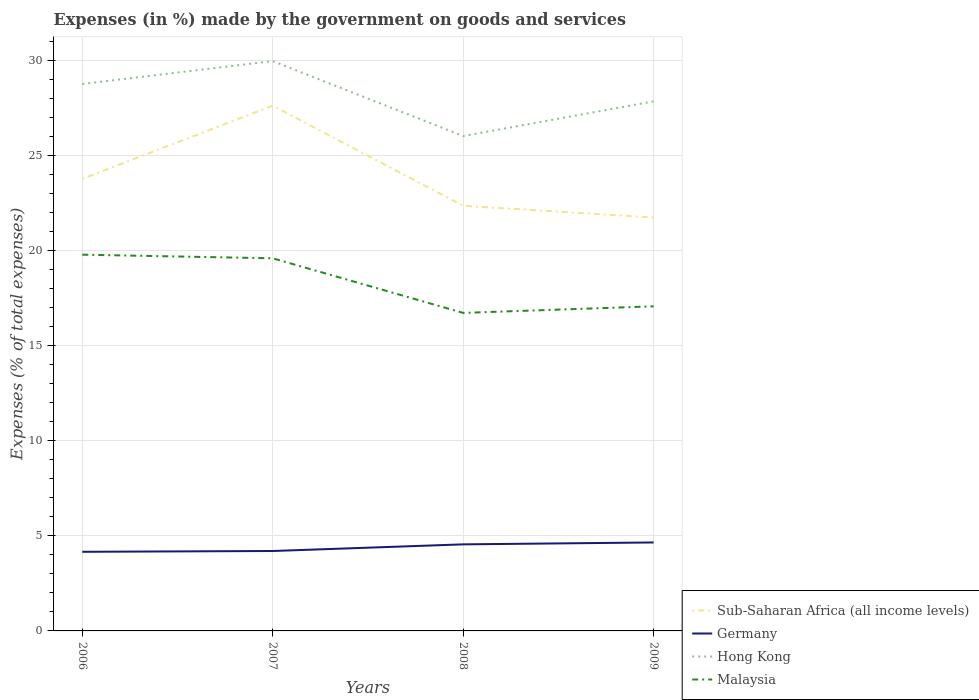Does the line corresponding to Malaysia intersect with the line corresponding to Hong Kong?
Keep it short and to the point. No. Across all years, what is the maximum percentage of expenses made by the government on goods and services in Malaysia?
Keep it short and to the point. 16.72. What is the total percentage of expenses made by the government on goods and services in Germany in the graph?
Offer a very short reply. -0.35. What is the difference between the highest and the second highest percentage of expenses made by the government on goods and services in Sub-Saharan Africa (all income levels)?
Offer a terse response. 5.88. What is the difference between the highest and the lowest percentage of expenses made by the government on goods and services in Malaysia?
Provide a short and direct response. 2. Is the percentage of expenses made by the government on goods and services in Germany strictly greater than the percentage of expenses made by the government on goods and services in Malaysia over the years?
Provide a short and direct response. Yes. How many lines are there?
Offer a very short reply. 4. What is the difference between two consecutive major ticks on the Y-axis?
Ensure brevity in your answer.  5. How are the legend labels stacked?
Offer a very short reply. Vertical. What is the title of the graph?
Provide a succinct answer. Expenses (in %) made by the government on goods and services. What is the label or title of the Y-axis?
Ensure brevity in your answer.  Expenses (% of total expenses). What is the Expenses (% of total expenses) in Sub-Saharan Africa (all income levels) in 2006?
Provide a succinct answer. 23.77. What is the Expenses (% of total expenses) of Germany in 2006?
Your answer should be compact. 4.16. What is the Expenses (% of total expenses) of Hong Kong in 2006?
Offer a terse response. 28.76. What is the Expenses (% of total expenses) in Malaysia in 2006?
Make the answer very short. 19.79. What is the Expenses (% of total expenses) in Sub-Saharan Africa (all income levels) in 2007?
Your response must be concise. 27.62. What is the Expenses (% of total expenses) of Germany in 2007?
Keep it short and to the point. 4.2. What is the Expenses (% of total expenses) of Hong Kong in 2007?
Provide a short and direct response. 29.97. What is the Expenses (% of total expenses) in Malaysia in 2007?
Offer a very short reply. 19.6. What is the Expenses (% of total expenses) in Sub-Saharan Africa (all income levels) in 2008?
Give a very brief answer. 22.36. What is the Expenses (% of total expenses) in Germany in 2008?
Offer a very short reply. 4.55. What is the Expenses (% of total expenses) in Hong Kong in 2008?
Give a very brief answer. 26.02. What is the Expenses (% of total expenses) of Malaysia in 2008?
Give a very brief answer. 16.72. What is the Expenses (% of total expenses) in Sub-Saharan Africa (all income levels) in 2009?
Your answer should be compact. 21.74. What is the Expenses (% of total expenses) in Germany in 2009?
Your response must be concise. 4.65. What is the Expenses (% of total expenses) in Hong Kong in 2009?
Offer a very short reply. 27.85. What is the Expenses (% of total expenses) of Malaysia in 2009?
Keep it short and to the point. 17.07. Across all years, what is the maximum Expenses (% of total expenses) of Sub-Saharan Africa (all income levels)?
Keep it short and to the point. 27.62. Across all years, what is the maximum Expenses (% of total expenses) in Germany?
Your answer should be compact. 4.65. Across all years, what is the maximum Expenses (% of total expenses) in Hong Kong?
Ensure brevity in your answer.  29.97. Across all years, what is the maximum Expenses (% of total expenses) in Malaysia?
Offer a terse response. 19.79. Across all years, what is the minimum Expenses (% of total expenses) in Sub-Saharan Africa (all income levels)?
Provide a succinct answer. 21.74. Across all years, what is the minimum Expenses (% of total expenses) in Germany?
Give a very brief answer. 4.16. Across all years, what is the minimum Expenses (% of total expenses) in Hong Kong?
Your response must be concise. 26.02. Across all years, what is the minimum Expenses (% of total expenses) of Malaysia?
Give a very brief answer. 16.72. What is the total Expenses (% of total expenses) in Sub-Saharan Africa (all income levels) in the graph?
Ensure brevity in your answer.  95.49. What is the total Expenses (% of total expenses) of Germany in the graph?
Your answer should be compact. 17.57. What is the total Expenses (% of total expenses) in Hong Kong in the graph?
Ensure brevity in your answer.  112.6. What is the total Expenses (% of total expenses) of Malaysia in the graph?
Your response must be concise. 73.18. What is the difference between the Expenses (% of total expenses) in Sub-Saharan Africa (all income levels) in 2006 and that in 2007?
Ensure brevity in your answer.  -3.85. What is the difference between the Expenses (% of total expenses) in Germany in 2006 and that in 2007?
Offer a terse response. -0.04. What is the difference between the Expenses (% of total expenses) of Hong Kong in 2006 and that in 2007?
Make the answer very short. -1.2. What is the difference between the Expenses (% of total expenses) of Malaysia in 2006 and that in 2007?
Offer a very short reply. 0.19. What is the difference between the Expenses (% of total expenses) in Sub-Saharan Africa (all income levels) in 2006 and that in 2008?
Offer a very short reply. 1.42. What is the difference between the Expenses (% of total expenses) of Germany in 2006 and that in 2008?
Offer a terse response. -0.39. What is the difference between the Expenses (% of total expenses) in Hong Kong in 2006 and that in 2008?
Give a very brief answer. 2.74. What is the difference between the Expenses (% of total expenses) in Malaysia in 2006 and that in 2008?
Make the answer very short. 3.06. What is the difference between the Expenses (% of total expenses) of Sub-Saharan Africa (all income levels) in 2006 and that in 2009?
Keep it short and to the point. 2.03. What is the difference between the Expenses (% of total expenses) in Germany in 2006 and that in 2009?
Ensure brevity in your answer.  -0.49. What is the difference between the Expenses (% of total expenses) in Hong Kong in 2006 and that in 2009?
Offer a very short reply. 0.91. What is the difference between the Expenses (% of total expenses) in Malaysia in 2006 and that in 2009?
Ensure brevity in your answer.  2.72. What is the difference between the Expenses (% of total expenses) of Sub-Saharan Africa (all income levels) in 2007 and that in 2008?
Ensure brevity in your answer.  5.26. What is the difference between the Expenses (% of total expenses) in Germany in 2007 and that in 2008?
Your answer should be very brief. -0.35. What is the difference between the Expenses (% of total expenses) of Hong Kong in 2007 and that in 2008?
Keep it short and to the point. 3.94. What is the difference between the Expenses (% of total expenses) of Malaysia in 2007 and that in 2008?
Your answer should be very brief. 2.87. What is the difference between the Expenses (% of total expenses) of Sub-Saharan Africa (all income levels) in 2007 and that in 2009?
Offer a terse response. 5.88. What is the difference between the Expenses (% of total expenses) in Germany in 2007 and that in 2009?
Your answer should be compact. -0.45. What is the difference between the Expenses (% of total expenses) of Hong Kong in 2007 and that in 2009?
Keep it short and to the point. 2.12. What is the difference between the Expenses (% of total expenses) in Malaysia in 2007 and that in 2009?
Make the answer very short. 2.52. What is the difference between the Expenses (% of total expenses) in Sub-Saharan Africa (all income levels) in 2008 and that in 2009?
Offer a very short reply. 0.62. What is the difference between the Expenses (% of total expenses) of Germany in 2008 and that in 2009?
Your answer should be very brief. -0.1. What is the difference between the Expenses (% of total expenses) in Hong Kong in 2008 and that in 2009?
Give a very brief answer. -1.82. What is the difference between the Expenses (% of total expenses) of Malaysia in 2008 and that in 2009?
Offer a terse response. -0.35. What is the difference between the Expenses (% of total expenses) in Sub-Saharan Africa (all income levels) in 2006 and the Expenses (% of total expenses) in Germany in 2007?
Offer a terse response. 19.57. What is the difference between the Expenses (% of total expenses) of Sub-Saharan Africa (all income levels) in 2006 and the Expenses (% of total expenses) of Hong Kong in 2007?
Make the answer very short. -6.19. What is the difference between the Expenses (% of total expenses) in Sub-Saharan Africa (all income levels) in 2006 and the Expenses (% of total expenses) in Malaysia in 2007?
Your response must be concise. 4.18. What is the difference between the Expenses (% of total expenses) in Germany in 2006 and the Expenses (% of total expenses) in Hong Kong in 2007?
Ensure brevity in your answer.  -25.8. What is the difference between the Expenses (% of total expenses) in Germany in 2006 and the Expenses (% of total expenses) in Malaysia in 2007?
Your answer should be compact. -15.43. What is the difference between the Expenses (% of total expenses) in Hong Kong in 2006 and the Expenses (% of total expenses) in Malaysia in 2007?
Your answer should be very brief. 9.17. What is the difference between the Expenses (% of total expenses) in Sub-Saharan Africa (all income levels) in 2006 and the Expenses (% of total expenses) in Germany in 2008?
Your response must be concise. 19.22. What is the difference between the Expenses (% of total expenses) of Sub-Saharan Africa (all income levels) in 2006 and the Expenses (% of total expenses) of Hong Kong in 2008?
Offer a terse response. -2.25. What is the difference between the Expenses (% of total expenses) in Sub-Saharan Africa (all income levels) in 2006 and the Expenses (% of total expenses) in Malaysia in 2008?
Provide a succinct answer. 7.05. What is the difference between the Expenses (% of total expenses) in Germany in 2006 and the Expenses (% of total expenses) in Hong Kong in 2008?
Give a very brief answer. -21.86. What is the difference between the Expenses (% of total expenses) in Germany in 2006 and the Expenses (% of total expenses) in Malaysia in 2008?
Give a very brief answer. -12.56. What is the difference between the Expenses (% of total expenses) of Hong Kong in 2006 and the Expenses (% of total expenses) of Malaysia in 2008?
Keep it short and to the point. 12.04. What is the difference between the Expenses (% of total expenses) of Sub-Saharan Africa (all income levels) in 2006 and the Expenses (% of total expenses) of Germany in 2009?
Offer a very short reply. 19.12. What is the difference between the Expenses (% of total expenses) in Sub-Saharan Africa (all income levels) in 2006 and the Expenses (% of total expenses) in Hong Kong in 2009?
Provide a succinct answer. -4.07. What is the difference between the Expenses (% of total expenses) of Sub-Saharan Africa (all income levels) in 2006 and the Expenses (% of total expenses) of Malaysia in 2009?
Give a very brief answer. 6.7. What is the difference between the Expenses (% of total expenses) of Germany in 2006 and the Expenses (% of total expenses) of Hong Kong in 2009?
Offer a very short reply. -23.69. What is the difference between the Expenses (% of total expenses) of Germany in 2006 and the Expenses (% of total expenses) of Malaysia in 2009?
Your answer should be compact. -12.91. What is the difference between the Expenses (% of total expenses) in Hong Kong in 2006 and the Expenses (% of total expenses) in Malaysia in 2009?
Provide a succinct answer. 11.69. What is the difference between the Expenses (% of total expenses) in Sub-Saharan Africa (all income levels) in 2007 and the Expenses (% of total expenses) in Germany in 2008?
Give a very brief answer. 23.07. What is the difference between the Expenses (% of total expenses) in Sub-Saharan Africa (all income levels) in 2007 and the Expenses (% of total expenses) in Hong Kong in 2008?
Make the answer very short. 1.6. What is the difference between the Expenses (% of total expenses) of Sub-Saharan Africa (all income levels) in 2007 and the Expenses (% of total expenses) of Malaysia in 2008?
Make the answer very short. 10.9. What is the difference between the Expenses (% of total expenses) of Germany in 2007 and the Expenses (% of total expenses) of Hong Kong in 2008?
Keep it short and to the point. -21.82. What is the difference between the Expenses (% of total expenses) in Germany in 2007 and the Expenses (% of total expenses) in Malaysia in 2008?
Give a very brief answer. -12.52. What is the difference between the Expenses (% of total expenses) of Hong Kong in 2007 and the Expenses (% of total expenses) of Malaysia in 2008?
Provide a succinct answer. 13.24. What is the difference between the Expenses (% of total expenses) in Sub-Saharan Africa (all income levels) in 2007 and the Expenses (% of total expenses) in Germany in 2009?
Your answer should be compact. 22.97. What is the difference between the Expenses (% of total expenses) of Sub-Saharan Africa (all income levels) in 2007 and the Expenses (% of total expenses) of Hong Kong in 2009?
Ensure brevity in your answer.  -0.23. What is the difference between the Expenses (% of total expenses) in Sub-Saharan Africa (all income levels) in 2007 and the Expenses (% of total expenses) in Malaysia in 2009?
Your response must be concise. 10.55. What is the difference between the Expenses (% of total expenses) in Germany in 2007 and the Expenses (% of total expenses) in Hong Kong in 2009?
Offer a very short reply. -23.65. What is the difference between the Expenses (% of total expenses) of Germany in 2007 and the Expenses (% of total expenses) of Malaysia in 2009?
Provide a short and direct response. -12.87. What is the difference between the Expenses (% of total expenses) of Hong Kong in 2007 and the Expenses (% of total expenses) of Malaysia in 2009?
Your response must be concise. 12.89. What is the difference between the Expenses (% of total expenses) in Sub-Saharan Africa (all income levels) in 2008 and the Expenses (% of total expenses) in Germany in 2009?
Offer a terse response. 17.7. What is the difference between the Expenses (% of total expenses) of Sub-Saharan Africa (all income levels) in 2008 and the Expenses (% of total expenses) of Hong Kong in 2009?
Ensure brevity in your answer.  -5.49. What is the difference between the Expenses (% of total expenses) of Sub-Saharan Africa (all income levels) in 2008 and the Expenses (% of total expenses) of Malaysia in 2009?
Make the answer very short. 5.29. What is the difference between the Expenses (% of total expenses) of Germany in 2008 and the Expenses (% of total expenses) of Hong Kong in 2009?
Give a very brief answer. -23.3. What is the difference between the Expenses (% of total expenses) of Germany in 2008 and the Expenses (% of total expenses) of Malaysia in 2009?
Your answer should be very brief. -12.52. What is the difference between the Expenses (% of total expenses) of Hong Kong in 2008 and the Expenses (% of total expenses) of Malaysia in 2009?
Your answer should be compact. 8.95. What is the average Expenses (% of total expenses) of Sub-Saharan Africa (all income levels) per year?
Make the answer very short. 23.87. What is the average Expenses (% of total expenses) of Germany per year?
Your answer should be very brief. 4.39. What is the average Expenses (% of total expenses) of Hong Kong per year?
Your response must be concise. 28.15. What is the average Expenses (% of total expenses) in Malaysia per year?
Keep it short and to the point. 18.29. In the year 2006, what is the difference between the Expenses (% of total expenses) in Sub-Saharan Africa (all income levels) and Expenses (% of total expenses) in Germany?
Provide a succinct answer. 19.61. In the year 2006, what is the difference between the Expenses (% of total expenses) in Sub-Saharan Africa (all income levels) and Expenses (% of total expenses) in Hong Kong?
Provide a succinct answer. -4.99. In the year 2006, what is the difference between the Expenses (% of total expenses) in Sub-Saharan Africa (all income levels) and Expenses (% of total expenses) in Malaysia?
Make the answer very short. 3.99. In the year 2006, what is the difference between the Expenses (% of total expenses) in Germany and Expenses (% of total expenses) in Hong Kong?
Provide a succinct answer. -24.6. In the year 2006, what is the difference between the Expenses (% of total expenses) of Germany and Expenses (% of total expenses) of Malaysia?
Offer a terse response. -15.63. In the year 2006, what is the difference between the Expenses (% of total expenses) in Hong Kong and Expenses (% of total expenses) in Malaysia?
Provide a short and direct response. 8.98. In the year 2007, what is the difference between the Expenses (% of total expenses) in Sub-Saharan Africa (all income levels) and Expenses (% of total expenses) in Germany?
Offer a very short reply. 23.42. In the year 2007, what is the difference between the Expenses (% of total expenses) in Sub-Saharan Africa (all income levels) and Expenses (% of total expenses) in Hong Kong?
Your response must be concise. -2.34. In the year 2007, what is the difference between the Expenses (% of total expenses) of Sub-Saharan Africa (all income levels) and Expenses (% of total expenses) of Malaysia?
Give a very brief answer. 8.03. In the year 2007, what is the difference between the Expenses (% of total expenses) of Germany and Expenses (% of total expenses) of Hong Kong?
Give a very brief answer. -25.76. In the year 2007, what is the difference between the Expenses (% of total expenses) in Germany and Expenses (% of total expenses) in Malaysia?
Give a very brief answer. -15.39. In the year 2007, what is the difference between the Expenses (% of total expenses) of Hong Kong and Expenses (% of total expenses) of Malaysia?
Keep it short and to the point. 10.37. In the year 2008, what is the difference between the Expenses (% of total expenses) in Sub-Saharan Africa (all income levels) and Expenses (% of total expenses) in Germany?
Your answer should be compact. 17.8. In the year 2008, what is the difference between the Expenses (% of total expenses) in Sub-Saharan Africa (all income levels) and Expenses (% of total expenses) in Hong Kong?
Your answer should be very brief. -3.67. In the year 2008, what is the difference between the Expenses (% of total expenses) in Sub-Saharan Africa (all income levels) and Expenses (% of total expenses) in Malaysia?
Give a very brief answer. 5.63. In the year 2008, what is the difference between the Expenses (% of total expenses) in Germany and Expenses (% of total expenses) in Hong Kong?
Provide a succinct answer. -21.47. In the year 2008, what is the difference between the Expenses (% of total expenses) in Germany and Expenses (% of total expenses) in Malaysia?
Ensure brevity in your answer.  -12.17. In the year 2008, what is the difference between the Expenses (% of total expenses) in Hong Kong and Expenses (% of total expenses) in Malaysia?
Provide a succinct answer. 9.3. In the year 2009, what is the difference between the Expenses (% of total expenses) in Sub-Saharan Africa (all income levels) and Expenses (% of total expenses) in Germany?
Provide a succinct answer. 17.09. In the year 2009, what is the difference between the Expenses (% of total expenses) of Sub-Saharan Africa (all income levels) and Expenses (% of total expenses) of Hong Kong?
Offer a terse response. -6.11. In the year 2009, what is the difference between the Expenses (% of total expenses) in Sub-Saharan Africa (all income levels) and Expenses (% of total expenses) in Malaysia?
Keep it short and to the point. 4.67. In the year 2009, what is the difference between the Expenses (% of total expenses) in Germany and Expenses (% of total expenses) in Hong Kong?
Make the answer very short. -23.2. In the year 2009, what is the difference between the Expenses (% of total expenses) of Germany and Expenses (% of total expenses) of Malaysia?
Provide a short and direct response. -12.42. In the year 2009, what is the difference between the Expenses (% of total expenses) in Hong Kong and Expenses (% of total expenses) in Malaysia?
Offer a terse response. 10.78. What is the ratio of the Expenses (% of total expenses) in Sub-Saharan Africa (all income levels) in 2006 to that in 2007?
Keep it short and to the point. 0.86. What is the ratio of the Expenses (% of total expenses) in Hong Kong in 2006 to that in 2007?
Give a very brief answer. 0.96. What is the ratio of the Expenses (% of total expenses) in Malaysia in 2006 to that in 2007?
Your answer should be very brief. 1.01. What is the ratio of the Expenses (% of total expenses) in Sub-Saharan Africa (all income levels) in 2006 to that in 2008?
Make the answer very short. 1.06. What is the ratio of the Expenses (% of total expenses) of Germany in 2006 to that in 2008?
Offer a very short reply. 0.91. What is the ratio of the Expenses (% of total expenses) in Hong Kong in 2006 to that in 2008?
Your response must be concise. 1.11. What is the ratio of the Expenses (% of total expenses) of Malaysia in 2006 to that in 2008?
Ensure brevity in your answer.  1.18. What is the ratio of the Expenses (% of total expenses) of Sub-Saharan Africa (all income levels) in 2006 to that in 2009?
Your answer should be compact. 1.09. What is the ratio of the Expenses (% of total expenses) of Germany in 2006 to that in 2009?
Ensure brevity in your answer.  0.89. What is the ratio of the Expenses (% of total expenses) in Hong Kong in 2006 to that in 2009?
Your response must be concise. 1.03. What is the ratio of the Expenses (% of total expenses) in Malaysia in 2006 to that in 2009?
Keep it short and to the point. 1.16. What is the ratio of the Expenses (% of total expenses) of Sub-Saharan Africa (all income levels) in 2007 to that in 2008?
Provide a short and direct response. 1.24. What is the ratio of the Expenses (% of total expenses) of Germany in 2007 to that in 2008?
Give a very brief answer. 0.92. What is the ratio of the Expenses (% of total expenses) of Hong Kong in 2007 to that in 2008?
Your answer should be compact. 1.15. What is the ratio of the Expenses (% of total expenses) of Malaysia in 2007 to that in 2008?
Your answer should be very brief. 1.17. What is the ratio of the Expenses (% of total expenses) of Sub-Saharan Africa (all income levels) in 2007 to that in 2009?
Provide a short and direct response. 1.27. What is the ratio of the Expenses (% of total expenses) in Germany in 2007 to that in 2009?
Provide a succinct answer. 0.9. What is the ratio of the Expenses (% of total expenses) in Hong Kong in 2007 to that in 2009?
Your answer should be compact. 1.08. What is the ratio of the Expenses (% of total expenses) of Malaysia in 2007 to that in 2009?
Your answer should be very brief. 1.15. What is the ratio of the Expenses (% of total expenses) of Sub-Saharan Africa (all income levels) in 2008 to that in 2009?
Your answer should be very brief. 1.03. What is the ratio of the Expenses (% of total expenses) of Germany in 2008 to that in 2009?
Provide a succinct answer. 0.98. What is the ratio of the Expenses (% of total expenses) of Hong Kong in 2008 to that in 2009?
Offer a terse response. 0.93. What is the ratio of the Expenses (% of total expenses) in Malaysia in 2008 to that in 2009?
Make the answer very short. 0.98. What is the difference between the highest and the second highest Expenses (% of total expenses) in Sub-Saharan Africa (all income levels)?
Your answer should be very brief. 3.85. What is the difference between the highest and the second highest Expenses (% of total expenses) of Germany?
Provide a short and direct response. 0.1. What is the difference between the highest and the second highest Expenses (% of total expenses) of Hong Kong?
Your answer should be very brief. 1.2. What is the difference between the highest and the second highest Expenses (% of total expenses) in Malaysia?
Keep it short and to the point. 0.19. What is the difference between the highest and the lowest Expenses (% of total expenses) in Sub-Saharan Africa (all income levels)?
Your answer should be compact. 5.88. What is the difference between the highest and the lowest Expenses (% of total expenses) of Germany?
Give a very brief answer. 0.49. What is the difference between the highest and the lowest Expenses (% of total expenses) of Hong Kong?
Your response must be concise. 3.94. What is the difference between the highest and the lowest Expenses (% of total expenses) in Malaysia?
Keep it short and to the point. 3.06. 